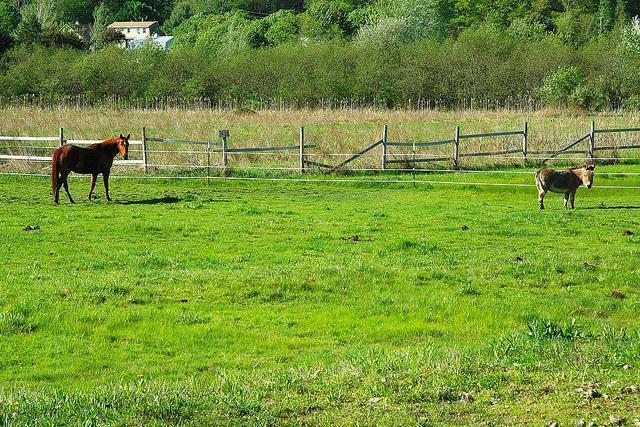How many animals are in the field?
Give a very brief answer. 2. 